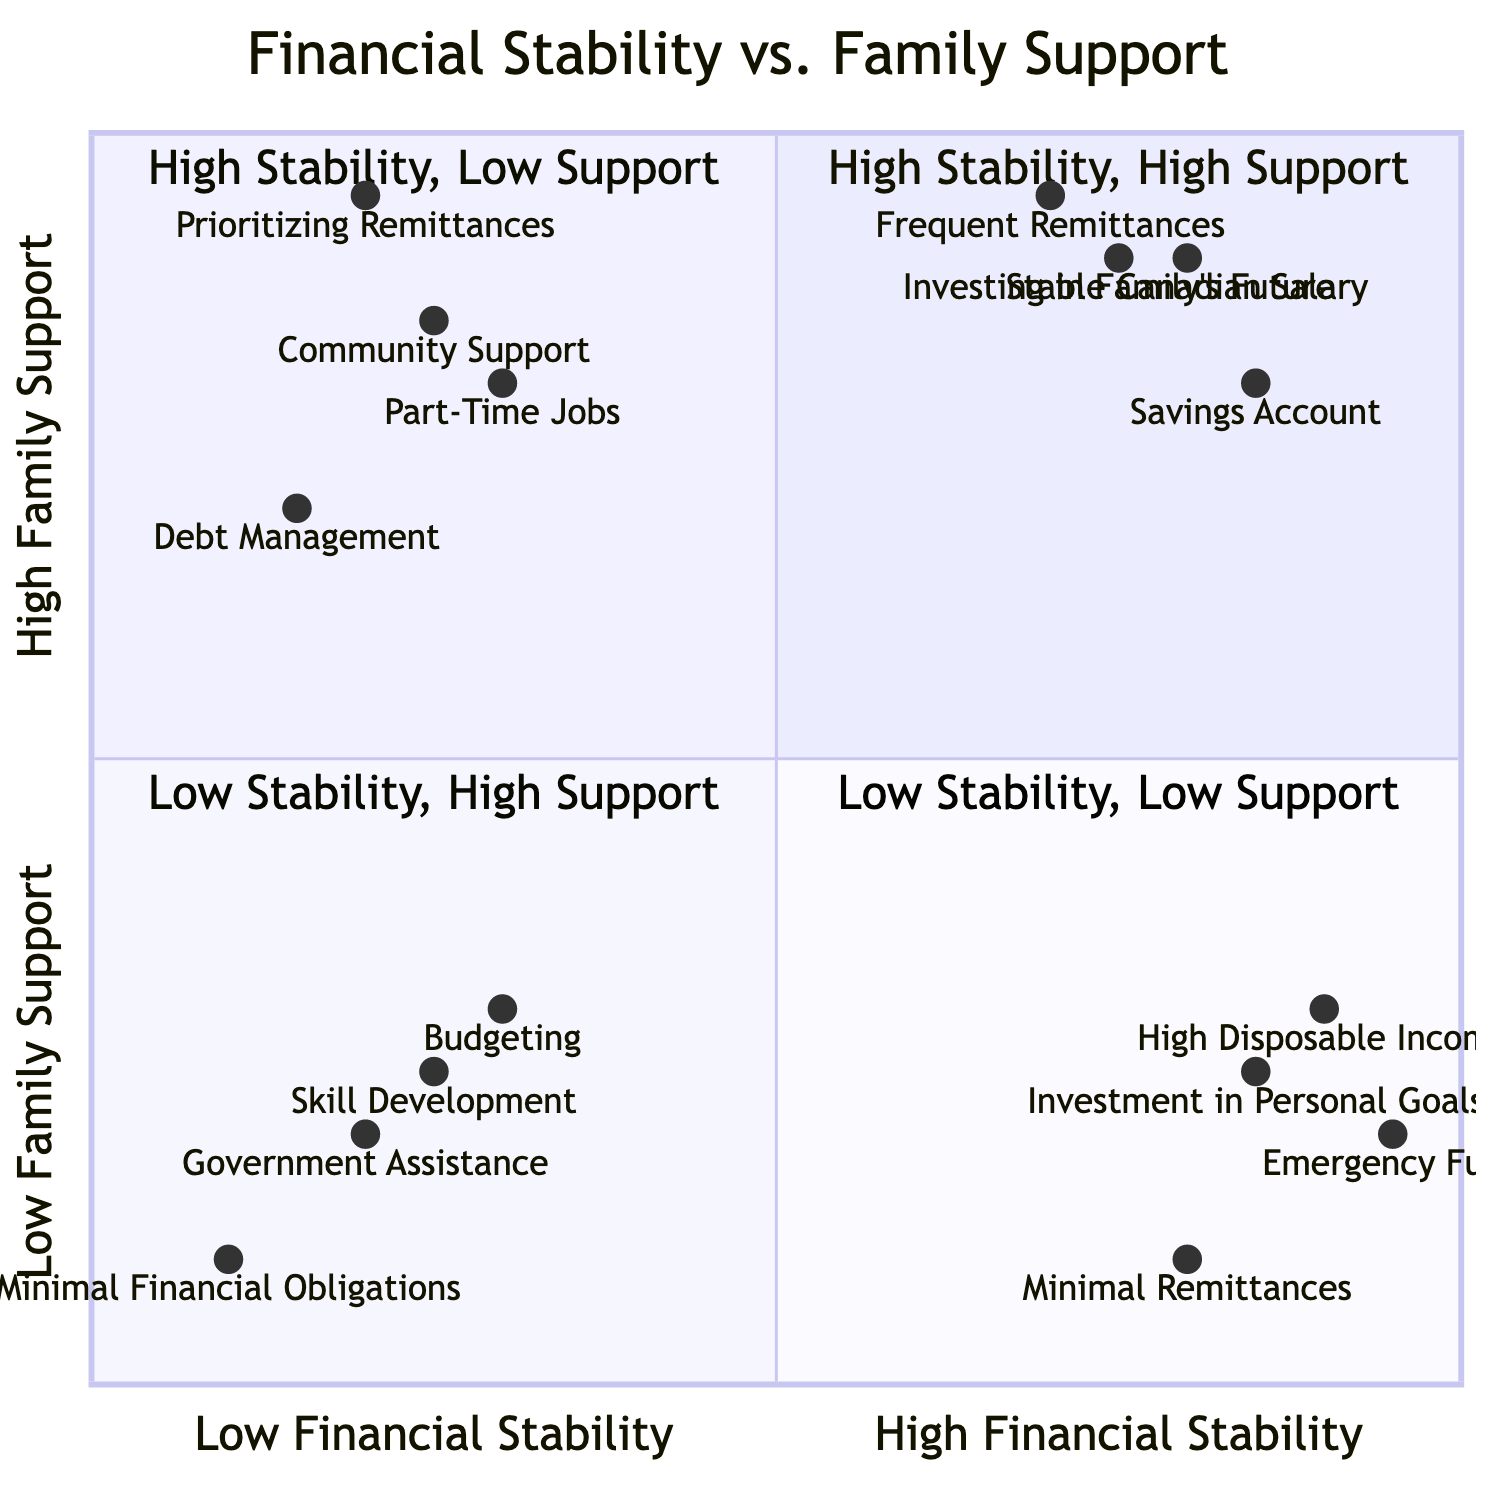What elements are found in the High Financial Stability - High Family Support quadrant? The High Financial Stability - High Family Support quadrant contains four elements: Stable Canadian Salary, Frequent Remittances, Savings Account, and Investing in Family's Future.
Answer: Stable Canadian Salary, Frequent Remittances, Savings Account, Investing in Family's Future How many elements are there in the Low Financial Stability - Low Family Support quadrant? There are four elements in the Low Financial Stability - Low Family Support quadrant: Budgeting, Government Assistance, Skill Development, and Minimal Financial Obligations.
Answer: 4 What is the relationship between High Disposable Income and Minimal Remittances? High Disposable Income is associated with a High Financial Stability and Low Family Support quadrant while Minimal Remittances belong to the High Financial Stability - Low Family Support quadrant, suggesting that both elements deal with low family support obligations.
Answer: Low family support What is the highest rated element in the Low Financial Stability - High Family Support quadrant? The highest rated element in this quadrant is Part-Time Jobs, which has coordinates [0.3, 0.8]. This means it has a relatively high family support while managing a low level of financial stability.
Answer: Part-Time Jobs Which quadrant contains the element 'Skill Development'? The element 'Skill Development' is located in the Low Financial Stability - Low Family Support quadrant, focusing on enhancing job prospects despite limited financial support.
Answer: Low Financial Stability - Low Family Support Which element has the highest value in the Financial Stability axis? The element with the highest value on the Financial Stability axis is Emergency Fund, which has a coordinate of [0.95, 0.2], indicating high financial stability.
Answer: Emergency Fund Explain how Prioritizing Remittances affects financial stability according to the diagram. Prioritizing Remittances, located in the Low Financial Stability - High Family Support quadrant with coordinates [0.2, 0.95], indicates that prioritizing family financial support significantly reduces one’s own financial stability.
Answer: Reduces financial stability What element represents the lowest level of family support among all quadrants? The element representing the lowest level of family support is Minimal Financial Obligations with coordinates [0.1, 0.1], indicating minimal financial obligations to family while focusing on personal recovery.
Answer: Minimal Financial Obligations 